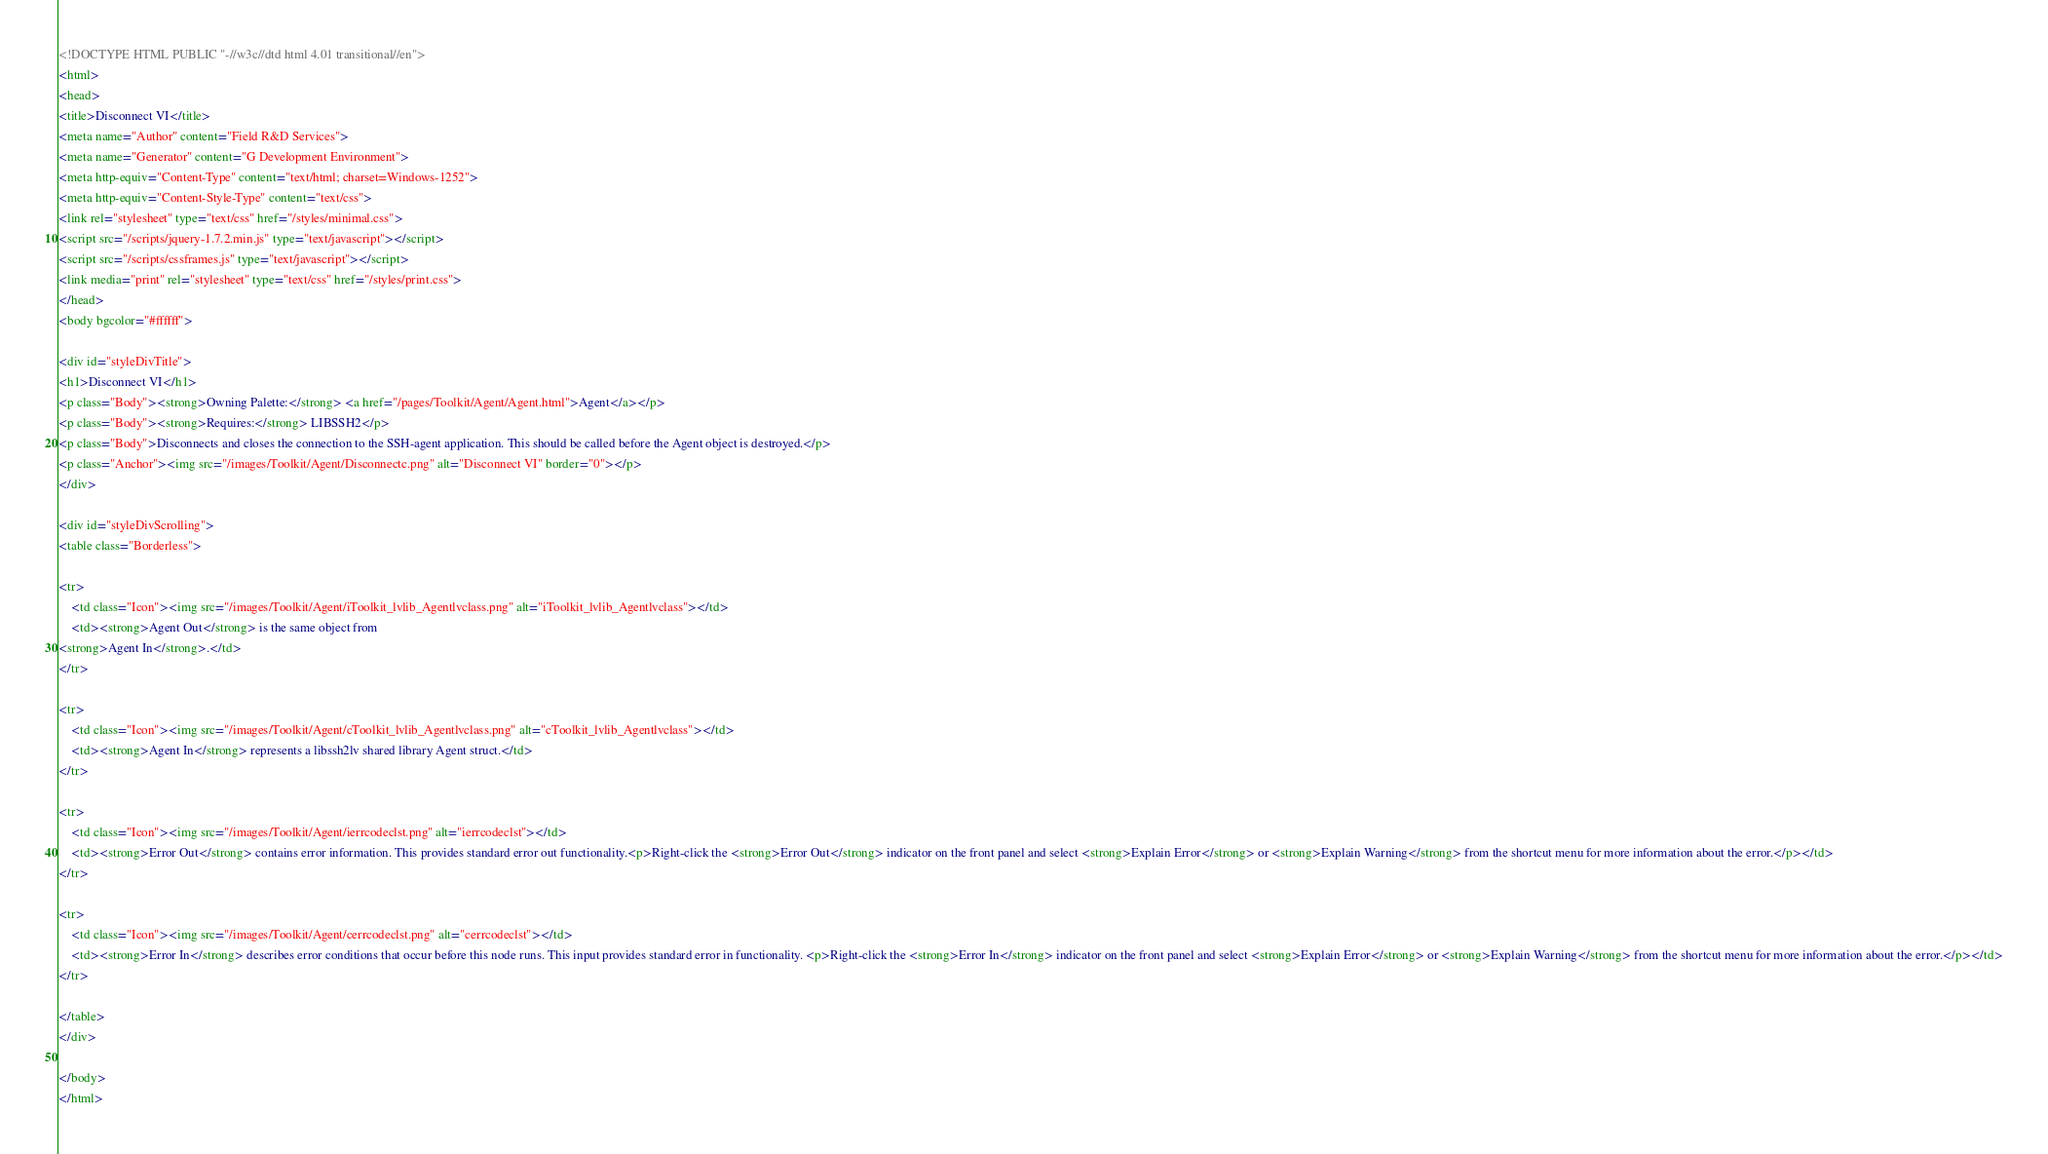<code> <loc_0><loc_0><loc_500><loc_500><_HTML_><!DOCTYPE HTML PUBLIC "-//w3c//dtd html 4.01 transitional//en">
<html>
<head>
<title>Disconnect VI</title>
<meta name="Author" content="Field R&D Services">
<meta name="Generator" content="G Development Environment">
<meta http-equiv="Content-Type" content="text/html; charset=Windows-1252">
<meta http-equiv="Content-Style-Type" content="text/css">
<link rel="stylesheet" type="text/css" href="/styles/minimal.css">
<script src="/scripts/jquery-1.7.2.min.js" type="text/javascript"></script>
<script src="/scripts/cssframes.js" type="text/javascript"></script>
<link media="print" rel="stylesheet" type="text/css" href="/styles/print.css">
</head>
<body bgcolor="#ffffff">

<div id="styleDivTitle">
<h1>Disconnect VI</h1>
<p class="Body"><strong>Owning Palette:</strong> <a href="/pages/Toolkit/Agent/Agent.html">Agent</a></p>
<p class="Body"><strong>Requires:</strong> LIBSSH2</p>
<p class="Body">Disconnects and closes the connection to the SSH-agent application. This should be called before the Agent object is destroyed.</p>
<p class="Anchor"><img src="/images/Toolkit/Agent/Disconnectc.png" alt="Disconnect VI" border="0"></p>
</div>

<div id="styleDivScrolling">
<table class="Borderless">

<tr>
    <td class="Icon"><img src="/images/Toolkit/Agent/iToolkit_lvlib_Agentlvclass.png" alt="iToolkit_lvlib_Agentlvclass"></td>
    <td><strong>Agent Out</strong> is the same object from 
<strong>Agent In</strong>.</td>
</tr>

<tr>
    <td class="Icon"><img src="/images/Toolkit/Agent/cToolkit_lvlib_Agentlvclass.png" alt="cToolkit_lvlib_Agentlvclass"></td>
    <td><strong>Agent In</strong> represents a libssh2lv shared library Agent struct.</td>
</tr>

<tr>
    <td class="Icon"><img src="/images/Toolkit/Agent/ierrcodeclst.png" alt="ierrcodeclst"></td>
    <td><strong>Error Out</strong> contains error information. This provides standard error out functionality.<p>Right-click the <strong>Error Out</strong> indicator on the front panel and select <strong>Explain Error</strong> or <strong>Explain Warning</strong> from the shortcut menu for more information about the error.</p></td>
</tr>

<tr>
    <td class="Icon"><img src="/images/Toolkit/Agent/cerrcodeclst.png" alt="cerrcodeclst"></td>
    <td><strong>Error In</strong> describes error conditions that occur before this node runs. This input provides standard error in functionality. <p>Right-click the <strong>Error In</strong> indicator on the front panel and select <strong>Explain Error</strong> or <strong>Explain Warning</strong> from the shortcut menu for more information about the error.</p></td>
</tr>

</table>
</div>

</body>
</html>
</code> 